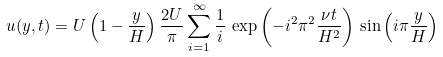<formula> <loc_0><loc_0><loc_500><loc_500>u ( y , t ) = U \left ( 1 - \frac { y } { H } \right ) \frac { 2 U } { \pi } \sum _ { i = 1 } ^ { \infty } \frac { 1 } { i } \, \exp \left ( - i ^ { 2 } \pi ^ { 2 } \frac { \nu t } { H ^ { 2 } } \right ) \, \sin \left ( i \pi \frac { y } { H } \right )</formula> 